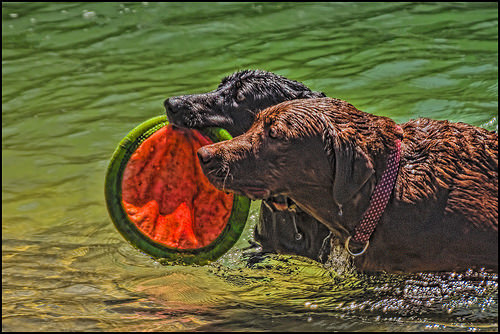<image>
Is the brown dog on the frisbee? No. The brown dog is not positioned on the frisbee. They may be near each other, but the brown dog is not supported by or resting on top of the frisbee. 